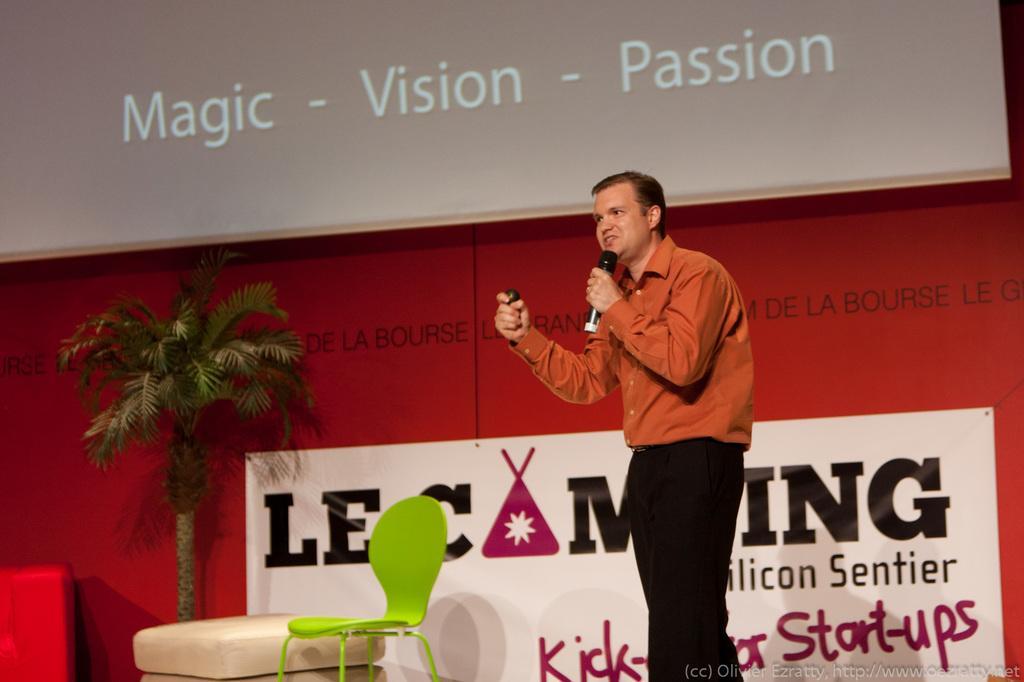In one or two sentences, can you explain what this image depicts? In this picture there is a man wearing orange color shirt giving a speech in the microphone. Behind we can see red and white color banner with small artificial coconut tree. Above we can see big projector screen. 